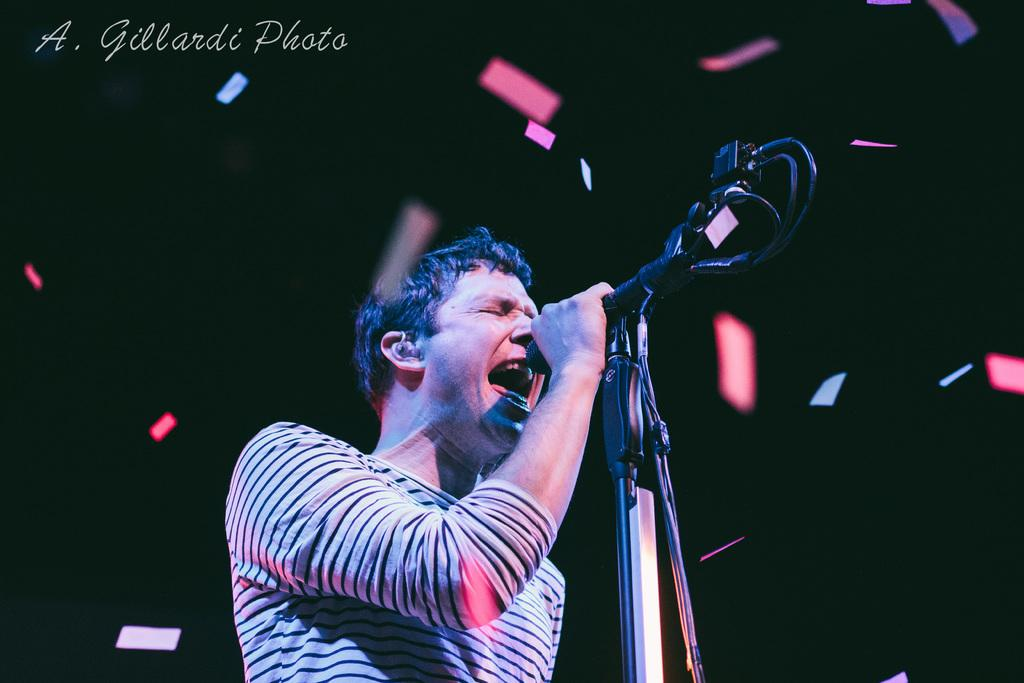Who is present in the image? There is a man in the image. What is the man doing in the image? The man is standing and holding a mic in his hand. What can be seen in the background of the image? There is confetti visible in the background of the image. How many toads are sitting on the man's shoulder in the image? There are no toads present in the image. What type of pleasure can be seen being experienced by the girls in the image? There are no girls present in the image. 